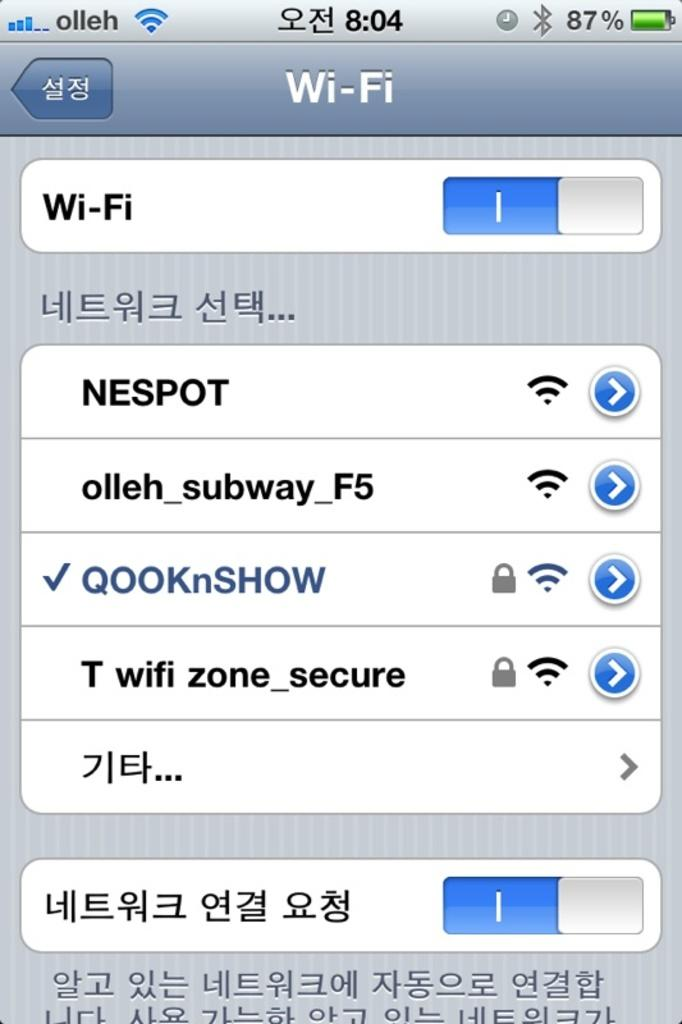<image>
Describe the image concisely. A screenshot of the available Wi-Fi networks, including NESPOT and olleh_subway_F5. 